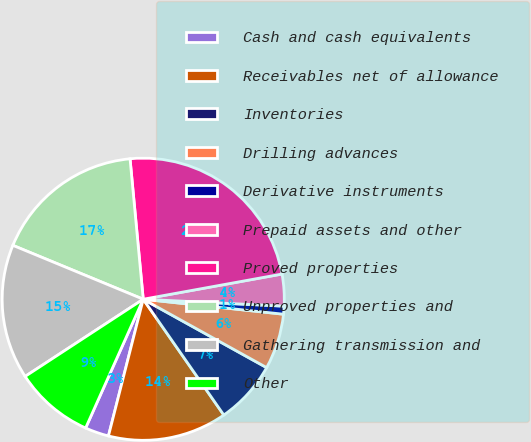Convert chart. <chart><loc_0><loc_0><loc_500><loc_500><pie_chart><fcel>Cash and cash equivalents<fcel>Receivables net of allowance<fcel>Inventories<fcel>Drilling advances<fcel>Derivative instruments<fcel>Prepaid assets and other<fcel>Proved properties<fcel>Unproved properties and<fcel>Gathering transmission and<fcel>Other<nl><fcel>2.73%<fcel>13.64%<fcel>7.27%<fcel>6.36%<fcel>0.91%<fcel>3.64%<fcel>23.63%<fcel>17.27%<fcel>15.45%<fcel>9.09%<nl></chart> 